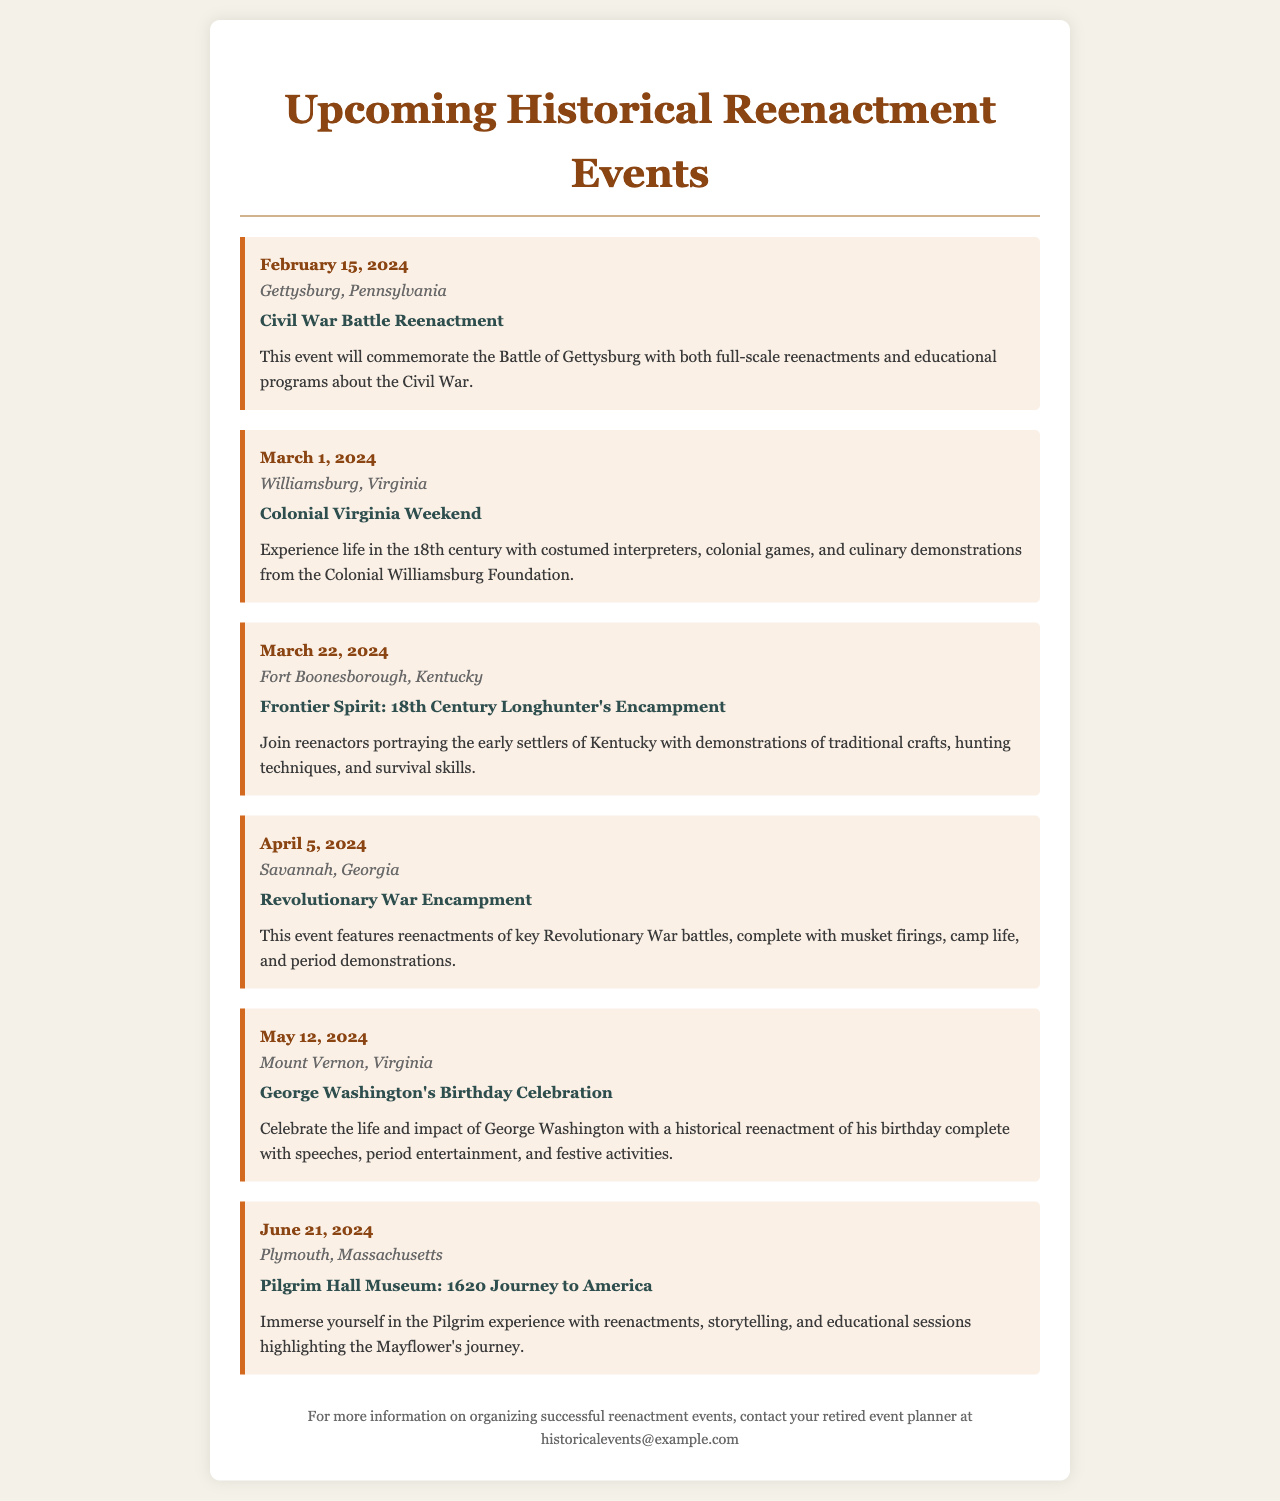What is the date of the Civil War Battle Reenactment? The date is specified in the event section, which lists February 15, 2024.
Answer: February 15, 2024 Where is the Colonial Virginia Weekend taking place? The location is mentioned alongside the event theme, stating Williamsburg, Virginia.
Answer: Williamsburg, Virginia What is the theme of the event on March 22, 2024? The theme for this date is provided in the event description as "Frontier Spirit: 18th Century Longhunter's Encampment."
Answer: Frontier Spirit: 18th Century Longhunter's Encampment How many events are listed in total for the next six months? By counting the events mentioned, there are six upcoming historical reenactment events.
Answer: Six Which event features George Washington's Birthday Celebration? This specific event detail includes the date of May 12, 2024, along with the title of the event.
Answer: May 12, 2024 What type of reenactment is featured in Savannah, Georgia? The document mentions a "Revolutionary War Encampment" as the event type for this location.
Answer: Revolutionary War Encampment What will participants experience during the Pilgrim Hall Museum event? The event description outlines experiences such as reenactments, storytelling, and educational sessions.
Answer: Reenactments, storytelling, and educational sessions What email address can be contacted for more information? The document provides an email located in the footer section for inquiries regarding organizing events.
Answer: historicalevents@example.com 